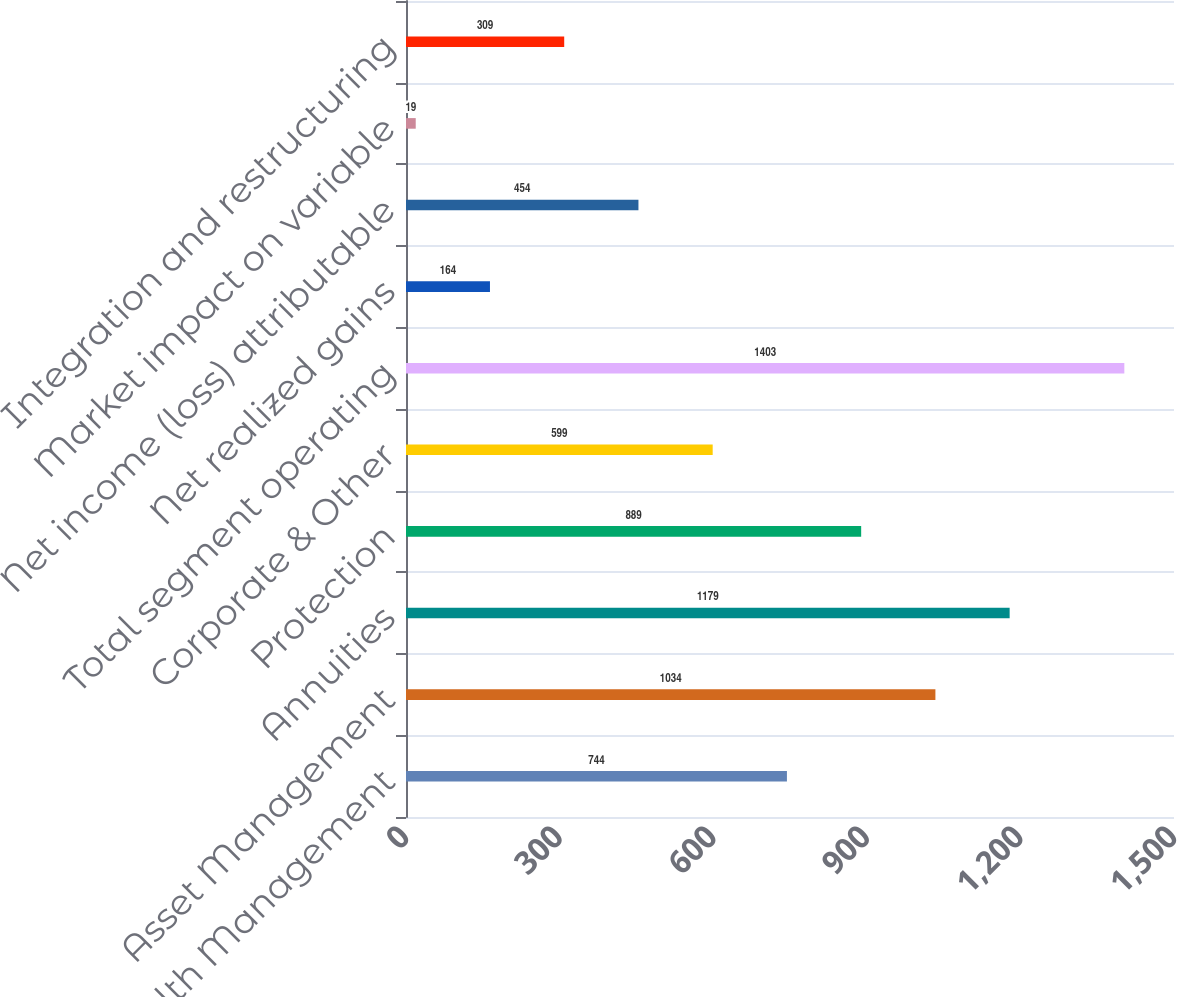<chart> <loc_0><loc_0><loc_500><loc_500><bar_chart><fcel>Advice & Wealth Management<fcel>Asset Management<fcel>Annuities<fcel>Protection<fcel>Corporate & Other<fcel>Total segment operating<fcel>Net realized gains<fcel>Net income (loss) attributable<fcel>Market impact on variable<fcel>Integration and restructuring<nl><fcel>744<fcel>1034<fcel>1179<fcel>889<fcel>599<fcel>1403<fcel>164<fcel>454<fcel>19<fcel>309<nl></chart> 